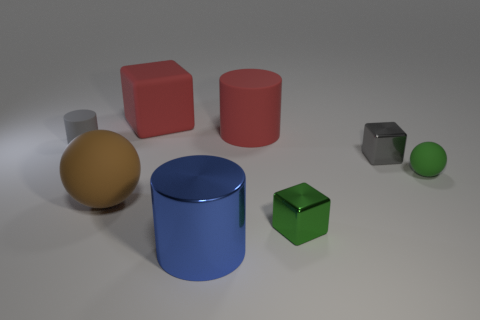Are there any small green blocks made of the same material as the large red cylinder?
Ensure brevity in your answer.  No. What is the size of the metal object that is the same color as the tiny ball?
Ensure brevity in your answer.  Small. There is a tiny object on the left side of the large red rubber thing that is in front of the big red block; are there any tiny gray objects that are right of it?
Ensure brevity in your answer.  Yes. Are there any small green objects behind the red cube?
Keep it short and to the point. No. What number of big brown rubber things are on the left side of the small metal cube in front of the tiny gray metallic cube?
Keep it short and to the point. 1. Does the gray shiny block have the same size as the blue object in front of the small green metallic cube?
Your answer should be compact. No. Are there any shiny cubes of the same color as the tiny rubber ball?
Your answer should be compact. Yes. What is the size of the other ball that is made of the same material as the big ball?
Provide a succinct answer. Small. Does the big red block have the same material as the blue cylinder?
Provide a short and direct response. No. What is the color of the small matte thing that is right of the large cylinder behind the tiny block in front of the tiny rubber sphere?
Make the answer very short. Green. 